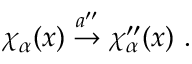Convert formula to latex. <formula><loc_0><loc_0><loc_500><loc_500>\chi _ { \alpha } ( x ) \stackrel { a ^ { \prime \prime } } { \rightarrow } \chi _ { \alpha } ^ { \prime \prime } ( x ) .</formula> 